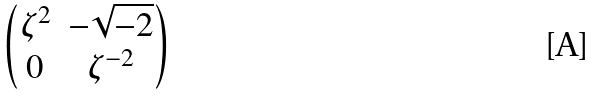Convert formula to latex. <formula><loc_0><loc_0><loc_500><loc_500>\begin{pmatrix} \zeta ^ { 2 } & - \sqrt { - 2 } \\ 0 & \zeta ^ { - 2 } \\ \end{pmatrix}</formula> 